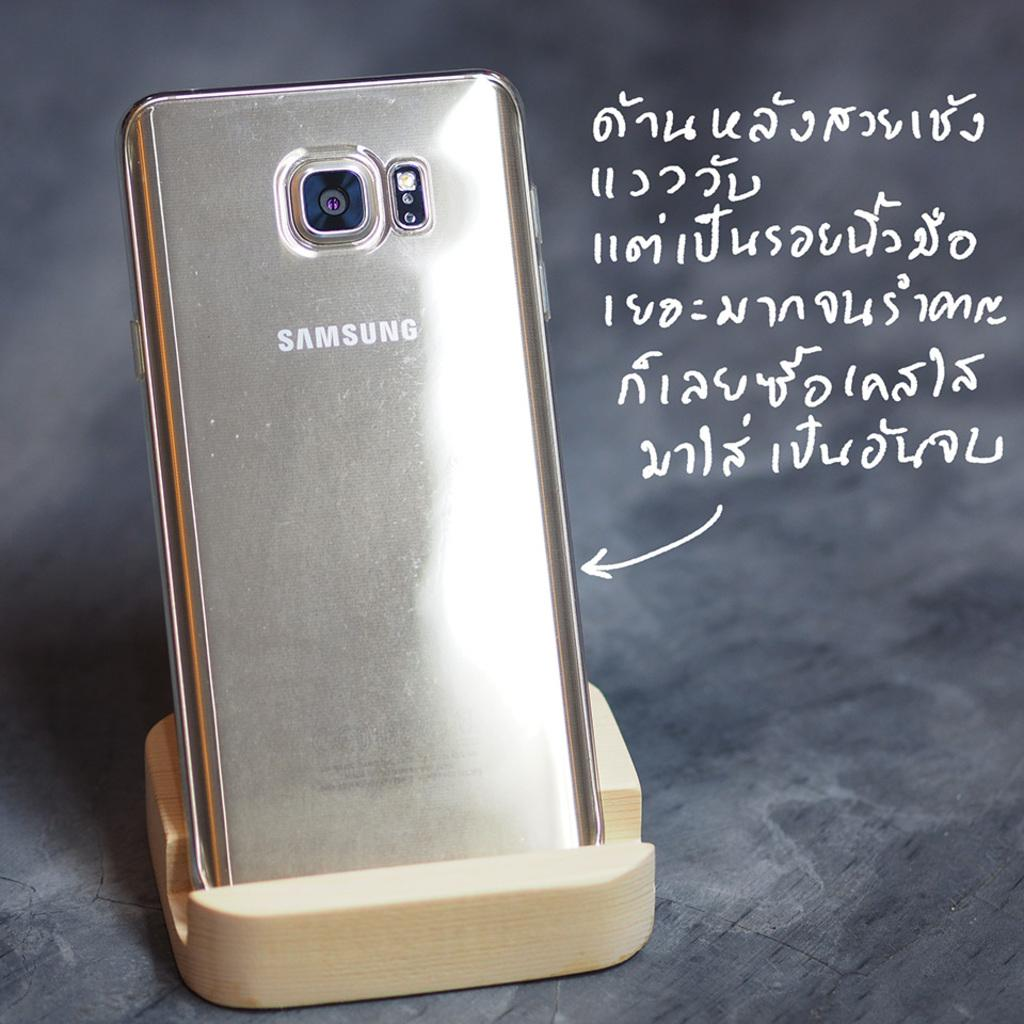<image>
Offer a succinct explanation of the picture presented. A samsung phone sitting in a holder with a foreign language written to the side.. 